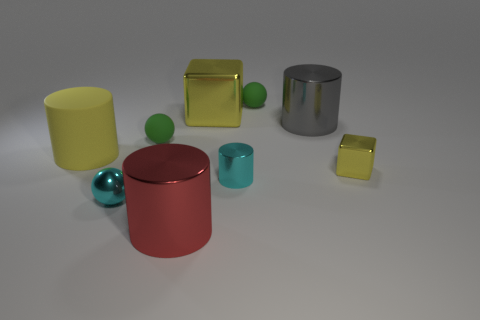What color is the other tiny metallic thing that is the same shape as the red object?
Offer a terse response. Cyan. How many green objects are in front of the yellow metallic object behind the large matte thing?
Your answer should be compact. 1. What number of blocks are either tiny green rubber objects or shiny objects?
Your answer should be compact. 2. Are there any red things?
Your answer should be compact. Yes. What is the size of the yellow rubber thing that is the same shape as the red shiny thing?
Provide a short and direct response. Large. What shape is the small shiny thing that is in front of the cyan thing that is to the right of the big yellow block?
Provide a succinct answer. Sphere. How many purple objects are either small rubber balls or big metal objects?
Offer a very short reply. 0. What is the color of the small shiny cylinder?
Your response must be concise. Cyan. Is the size of the yellow matte thing the same as the cyan cylinder?
Provide a succinct answer. No. Is the small cyan cylinder made of the same material as the tiny thing behind the big gray thing?
Make the answer very short. No. 